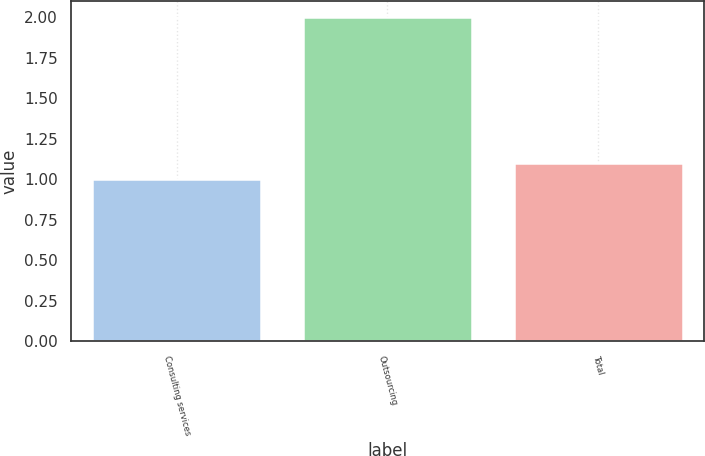Convert chart to OTSL. <chart><loc_0><loc_0><loc_500><loc_500><bar_chart><fcel>Consulting services<fcel>Outsourcing<fcel>Total<nl><fcel>1<fcel>2<fcel>1.1<nl></chart> 